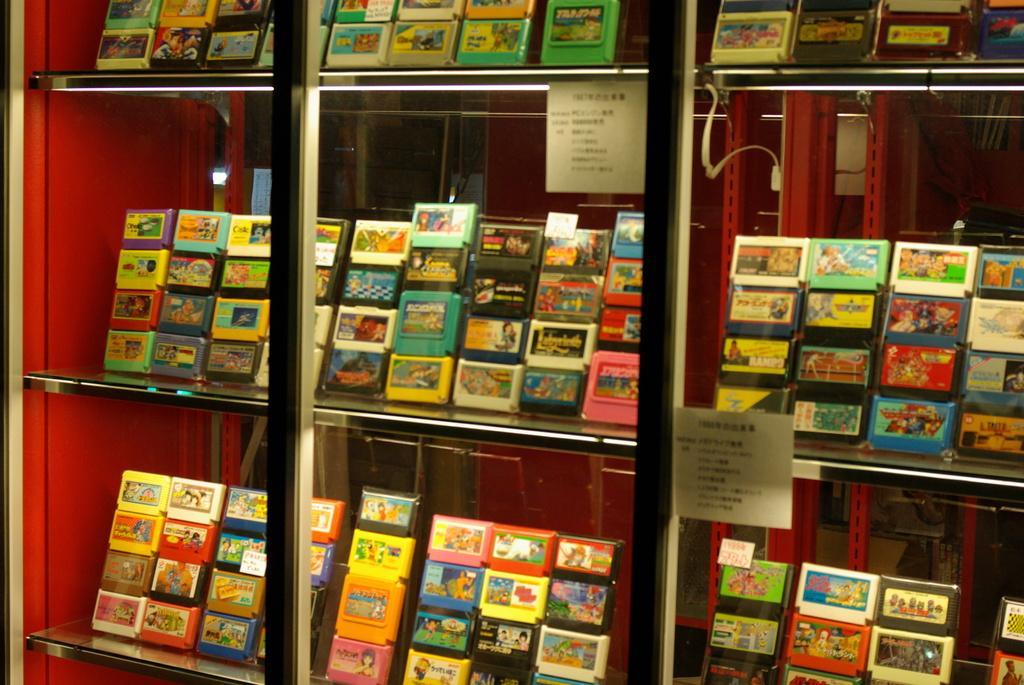Can you describe this image briefly? In the center of the image there are objects arranged in a glass shelf. 